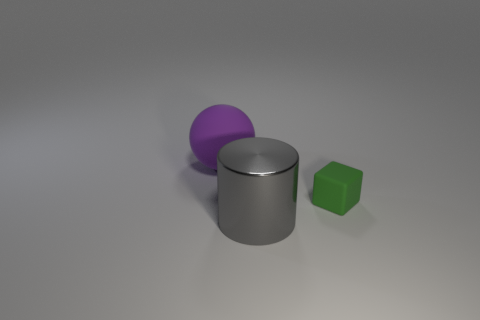Are there any other things that are the same size as the green rubber thing?
Your answer should be compact. No. What is the thing left of the gray object made of?
Keep it short and to the point. Rubber. Do the gray metal object and the large purple object have the same shape?
Your answer should be compact. No. How many other things are the same shape as the large purple object?
Keep it short and to the point. 0. What is the color of the matte thing to the left of the gray metallic cylinder?
Make the answer very short. Purple. Do the shiny thing and the rubber cube have the same size?
Provide a succinct answer. No. What material is the large thing behind the object to the right of the big shiny thing?
Your answer should be very brief. Rubber. Is there any other thing that has the same material as the gray object?
Make the answer very short. No. Are there fewer green things behind the large rubber ball than big rubber objects?
Offer a terse response. Yes. There is a big object behind the cylinder on the left side of the tiny rubber cube; what color is it?
Give a very brief answer. Purple. 